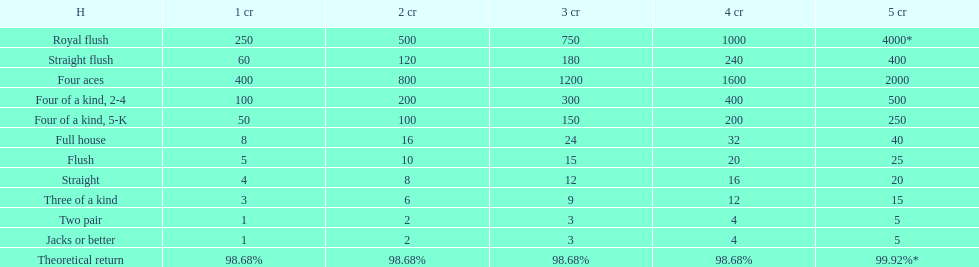How many straight wins at 3 credits equals one straight flush win at two credits? 10. 